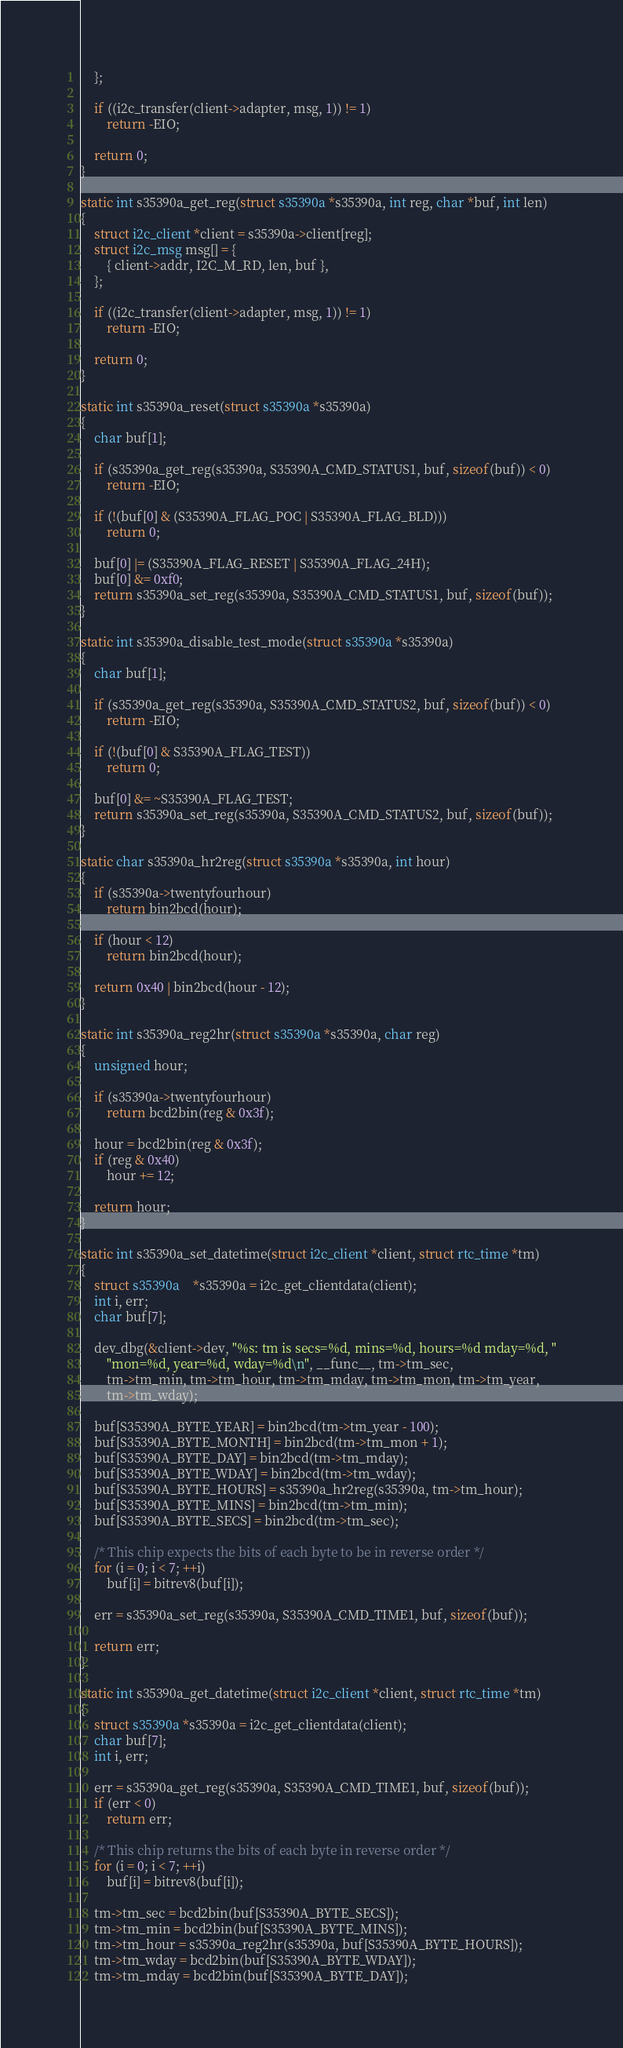<code> <loc_0><loc_0><loc_500><loc_500><_C_>	};

	if ((i2c_transfer(client->adapter, msg, 1)) != 1)
		return -EIO;

	return 0;
}

static int s35390a_get_reg(struct s35390a *s35390a, int reg, char *buf, int len)
{
	struct i2c_client *client = s35390a->client[reg];
	struct i2c_msg msg[] = {
		{ client->addr, I2C_M_RD, len, buf },
	};

	if ((i2c_transfer(client->adapter, msg, 1)) != 1)
		return -EIO;

	return 0;
}

static int s35390a_reset(struct s35390a *s35390a)
{
	char buf[1];

	if (s35390a_get_reg(s35390a, S35390A_CMD_STATUS1, buf, sizeof(buf)) < 0)
		return -EIO;

	if (!(buf[0] & (S35390A_FLAG_POC | S35390A_FLAG_BLD)))
		return 0;

	buf[0] |= (S35390A_FLAG_RESET | S35390A_FLAG_24H);
	buf[0] &= 0xf0;
	return s35390a_set_reg(s35390a, S35390A_CMD_STATUS1, buf, sizeof(buf));
}

static int s35390a_disable_test_mode(struct s35390a *s35390a)
{
	char buf[1];

	if (s35390a_get_reg(s35390a, S35390A_CMD_STATUS2, buf, sizeof(buf)) < 0)
		return -EIO;

	if (!(buf[0] & S35390A_FLAG_TEST))
		return 0;

	buf[0] &= ~S35390A_FLAG_TEST;
	return s35390a_set_reg(s35390a, S35390A_CMD_STATUS2, buf, sizeof(buf));
}

static char s35390a_hr2reg(struct s35390a *s35390a, int hour)
{
	if (s35390a->twentyfourhour)
		return bin2bcd(hour);

	if (hour < 12)
		return bin2bcd(hour);

	return 0x40 | bin2bcd(hour - 12);
}

static int s35390a_reg2hr(struct s35390a *s35390a, char reg)
{
	unsigned hour;

	if (s35390a->twentyfourhour)
		return bcd2bin(reg & 0x3f);

	hour = bcd2bin(reg & 0x3f);
	if (reg & 0x40)
		hour += 12;

	return hour;
}

static int s35390a_set_datetime(struct i2c_client *client, struct rtc_time *tm)
{
	struct s35390a	*s35390a = i2c_get_clientdata(client);
	int i, err;
	char buf[7];

	dev_dbg(&client->dev, "%s: tm is secs=%d, mins=%d, hours=%d mday=%d, "
		"mon=%d, year=%d, wday=%d\n", __func__, tm->tm_sec,
		tm->tm_min, tm->tm_hour, tm->tm_mday, tm->tm_mon, tm->tm_year,
		tm->tm_wday);

	buf[S35390A_BYTE_YEAR] = bin2bcd(tm->tm_year - 100);
	buf[S35390A_BYTE_MONTH] = bin2bcd(tm->tm_mon + 1);
	buf[S35390A_BYTE_DAY] = bin2bcd(tm->tm_mday);
	buf[S35390A_BYTE_WDAY] = bin2bcd(tm->tm_wday);
	buf[S35390A_BYTE_HOURS] = s35390a_hr2reg(s35390a, tm->tm_hour);
	buf[S35390A_BYTE_MINS] = bin2bcd(tm->tm_min);
	buf[S35390A_BYTE_SECS] = bin2bcd(tm->tm_sec);

	/* This chip expects the bits of each byte to be in reverse order */
	for (i = 0; i < 7; ++i)
		buf[i] = bitrev8(buf[i]);

	err = s35390a_set_reg(s35390a, S35390A_CMD_TIME1, buf, sizeof(buf));

	return err;
}

static int s35390a_get_datetime(struct i2c_client *client, struct rtc_time *tm)
{
	struct s35390a *s35390a = i2c_get_clientdata(client);
	char buf[7];
	int i, err;

	err = s35390a_get_reg(s35390a, S35390A_CMD_TIME1, buf, sizeof(buf));
	if (err < 0)
		return err;

	/* This chip returns the bits of each byte in reverse order */
	for (i = 0; i < 7; ++i)
		buf[i] = bitrev8(buf[i]);

	tm->tm_sec = bcd2bin(buf[S35390A_BYTE_SECS]);
	tm->tm_min = bcd2bin(buf[S35390A_BYTE_MINS]);
	tm->tm_hour = s35390a_reg2hr(s35390a, buf[S35390A_BYTE_HOURS]);
	tm->tm_wday = bcd2bin(buf[S35390A_BYTE_WDAY]);
	tm->tm_mday = bcd2bin(buf[S35390A_BYTE_DAY]);</code> 